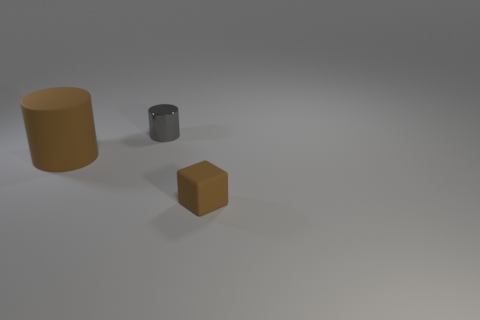Is the shape of the rubber object left of the small gray metal cylinder the same as the thing that is behind the big cylinder? The shape of the rubber object to the left of the small gray metal cylinder indeed appears to be the same as the shape of the thing behind the large cylinder – both are cubical. Upon careful observation, both objects share the characteristic of having six sides, with each side being a square, which is the defining feature of a cube. 